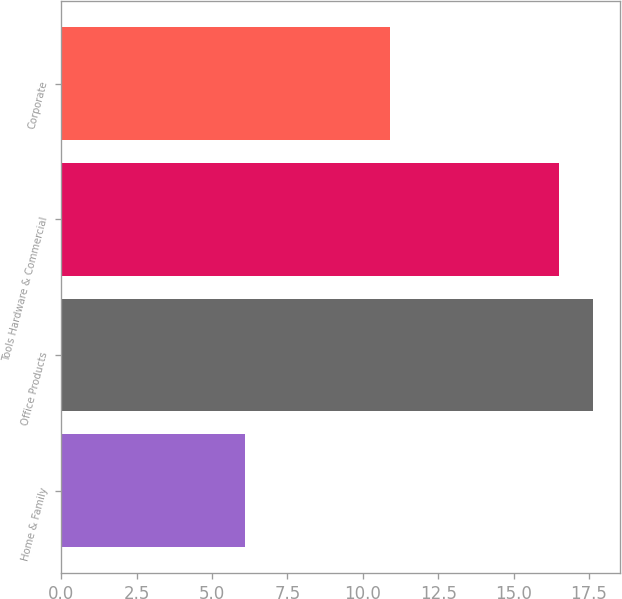Convert chart to OTSL. <chart><loc_0><loc_0><loc_500><loc_500><bar_chart><fcel>Home & Family<fcel>Office Products<fcel>Tools Hardware & Commercial<fcel>Corporate<nl><fcel>6.1<fcel>17.64<fcel>16.5<fcel>10.9<nl></chart> 